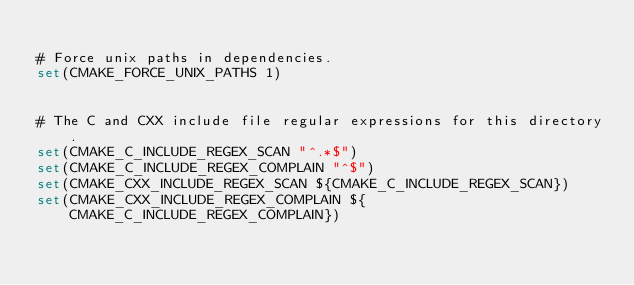Convert code to text. <code><loc_0><loc_0><loc_500><loc_500><_CMake_>
# Force unix paths in dependencies.
set(CMAKE_FORCE_UNIX_PATHS 1)


# The C and CXX include file regular expressions for this directory.
set(CMAKE_C_INCLUDE_REGEX_SCAN "^.*$")
set(CMAKE_C_INCLUDE_REGEX_COMPLAIN "^$")
set(CMAKE_CXX_INCLUDE_REGEX_SCAN ${CMAKE_C_INCLUDE_REGEX_SCAN})
set(CMAKE_CXX_INCLUDE_REGEX_COMPLAIN ${CMAKE_C_INCLUDE_REGEX_COMPLAIN})
</code> 